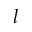<formula> <loc_0><loc_0><loc_500><loc_500>l</formula> 